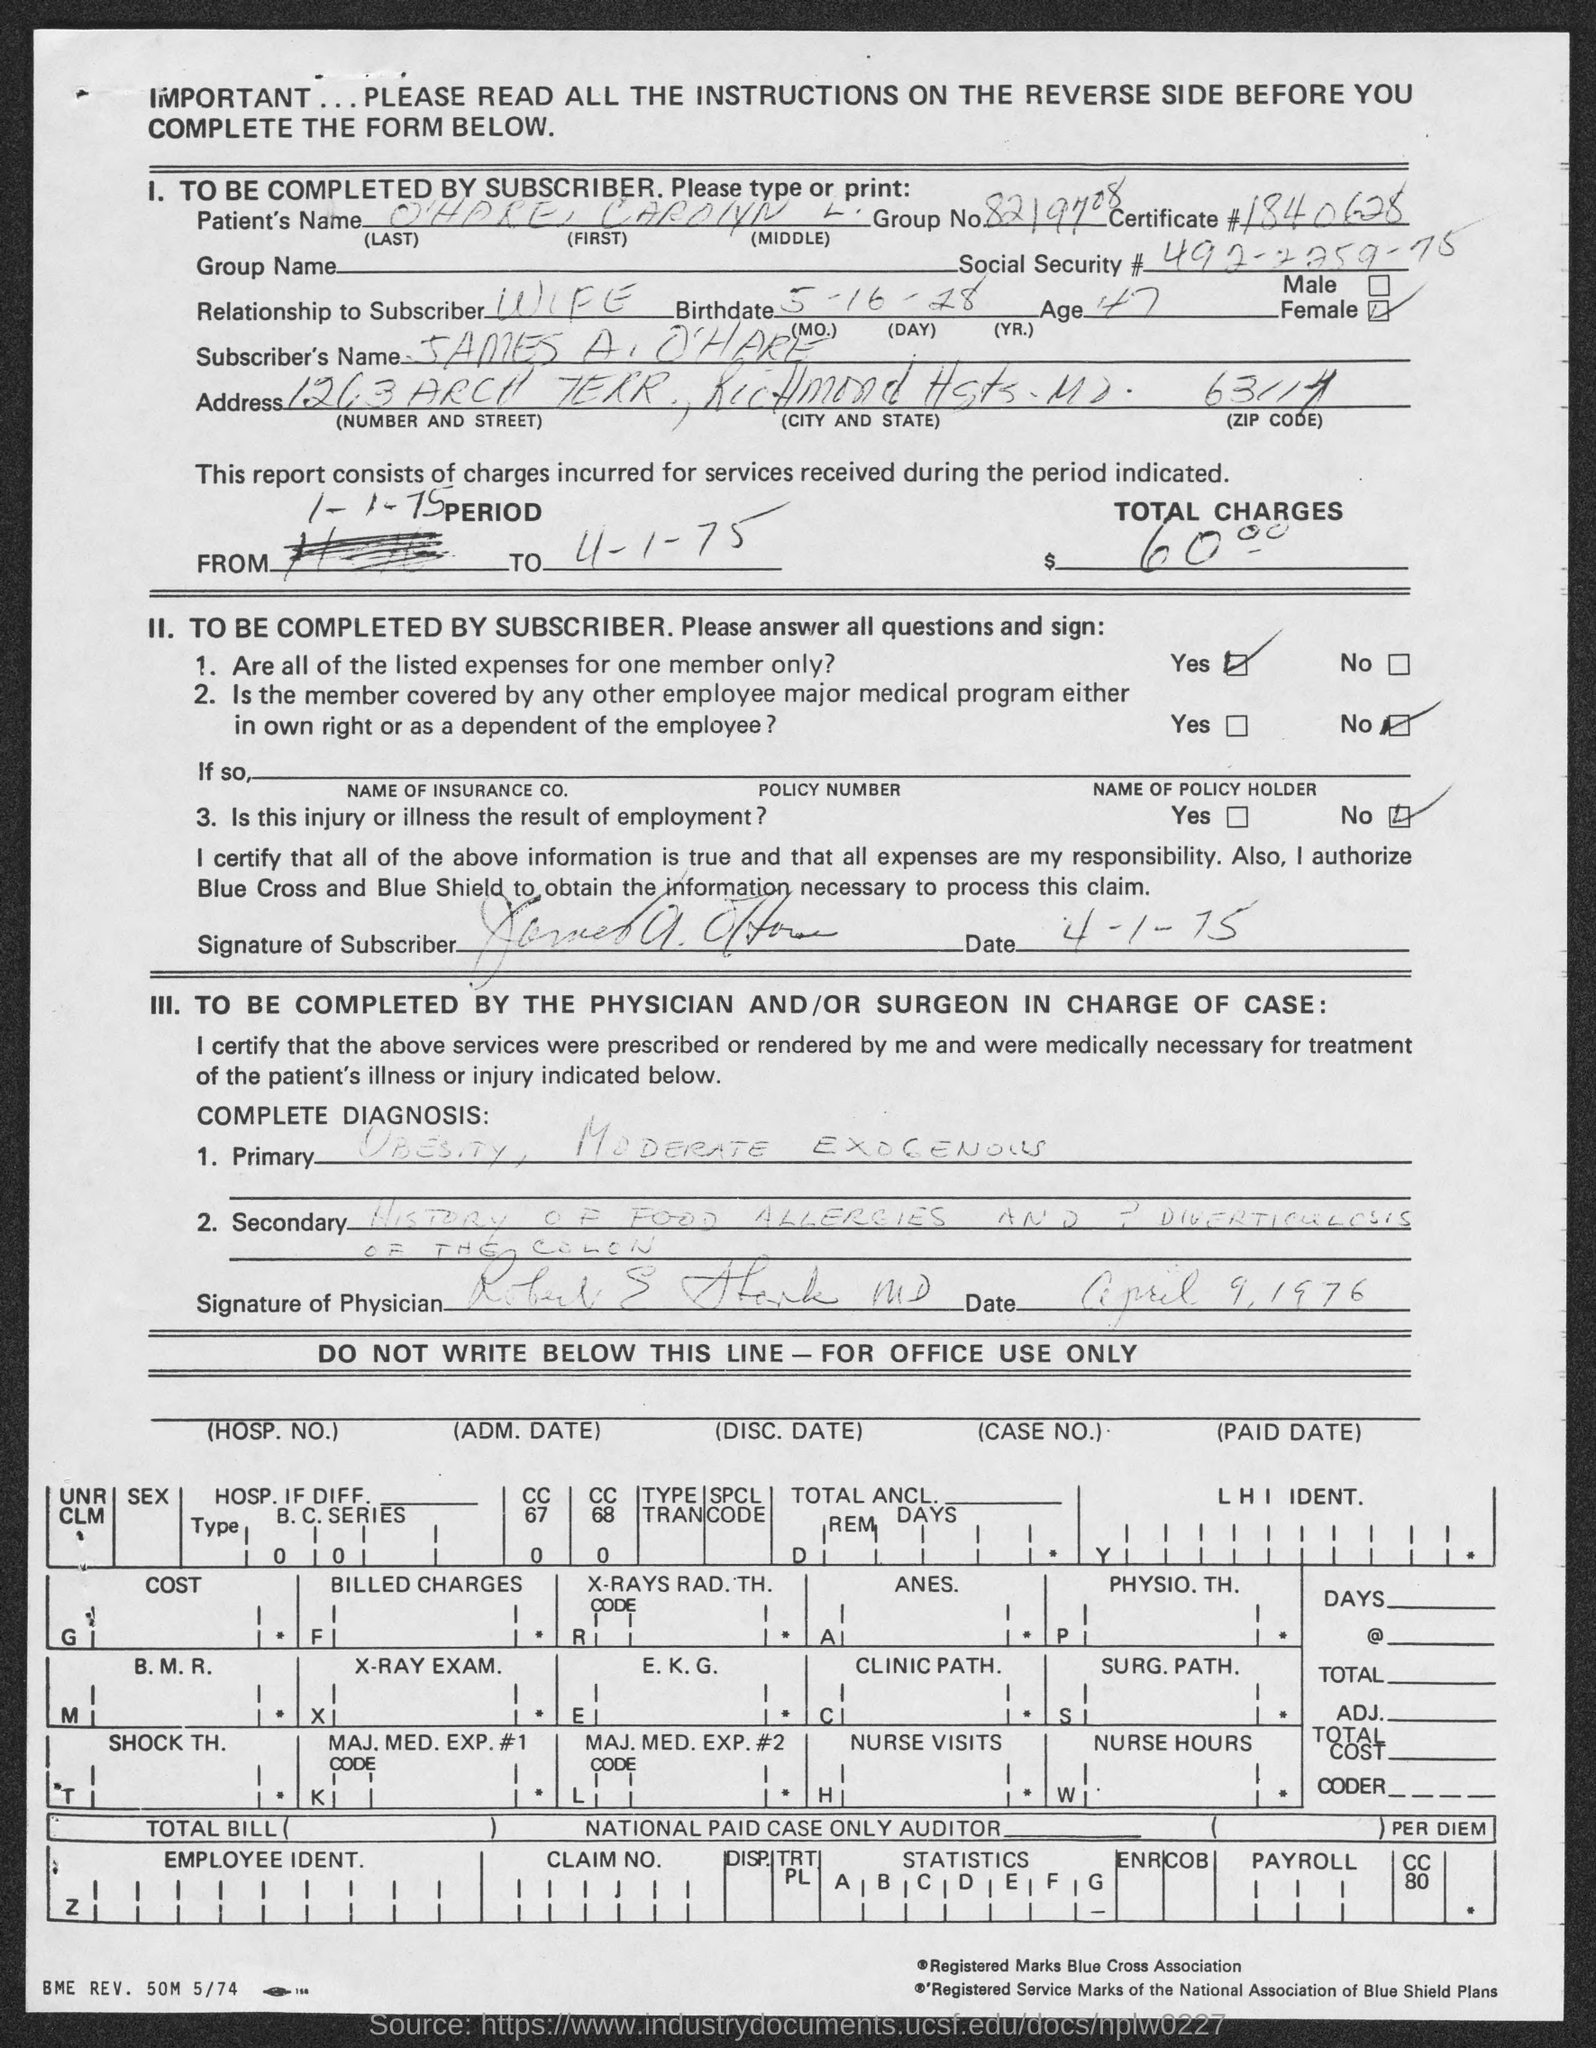Point out several critical features in this image. What is the certificate number? 1840628... The group number is 8219708... The subscriber is the wife. The patient's name is O'Hare Carolyn L. The subscriber's name is James A. O'Hare. 